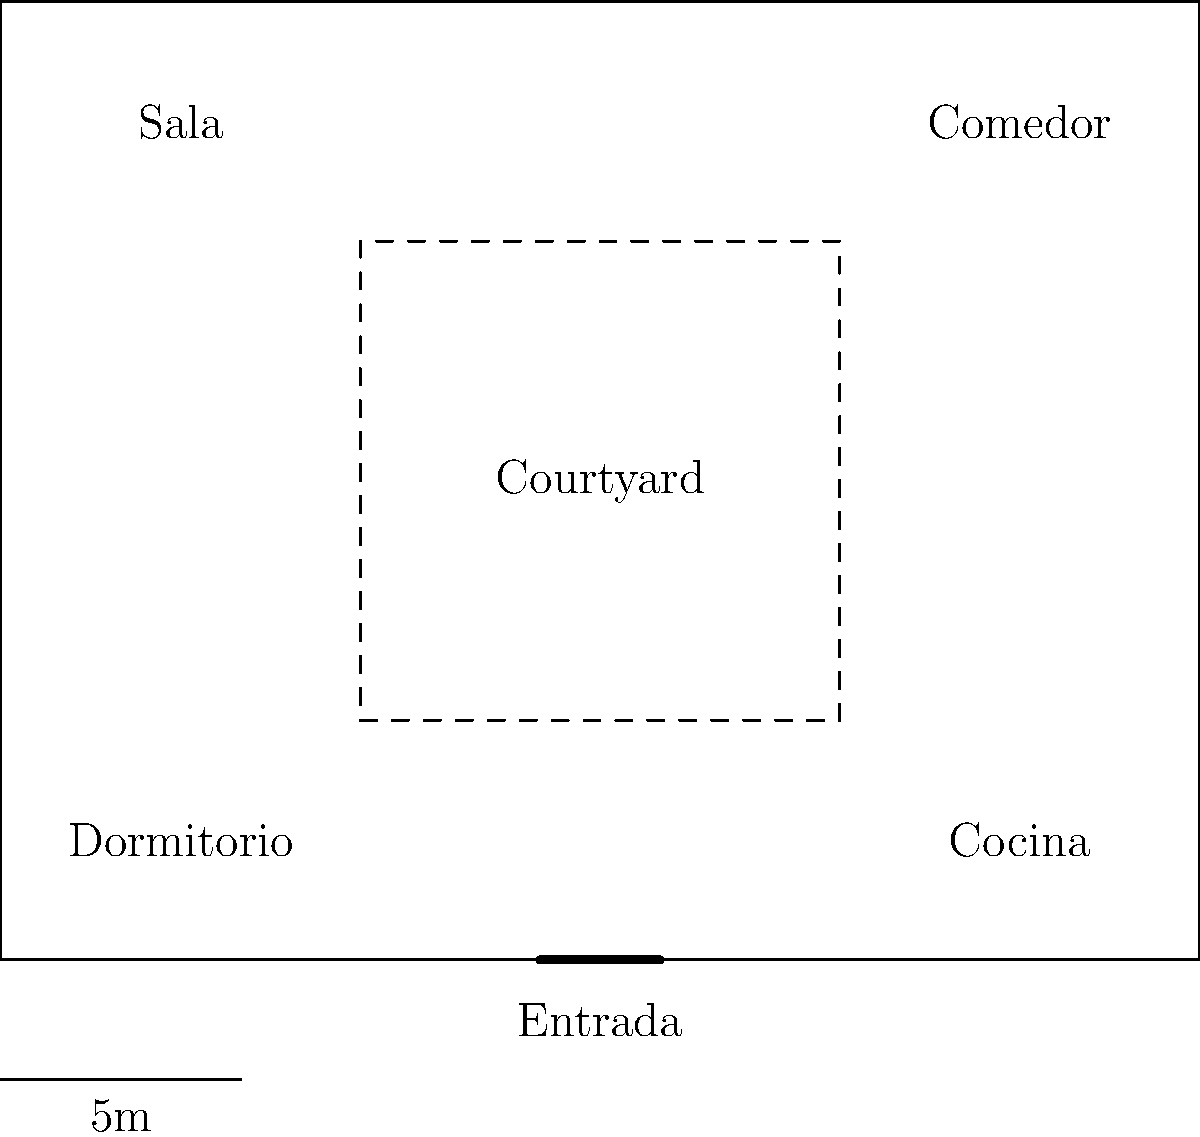In the floor plan of a typical Cuban colonial courtyard house shown above, which architectural element serves as the central organizing feature of the home's layout? To answer this question, let's analyze the floor plan step-by-step:

1. The diagram shows a rectangular structure with rooms arranged around a central space.

2. This central space is labeled "Courtyard" and is represented by a dashed line, indicating an open area.

3. The rooms are arranged around this courtyard:
   - "Sala" (living room) and "Comedor" (dining room) are located on one side
   - "Dormitorio" (bedroom) and "Cocina" (kitchen) are on the opposite side

4. The entrance ("Entrada") is shown at the bottom of the diagram, leading directly to the courtyard area.

5. This layout is characteristic of Cuban colonial architecture, where the courtyard (or "patio") serves as the heart of the home.

6. The courtyard provides:
   - Natural light and ventilation to surrounding rooms
   - A central gathering space for family activities
   - A way to organize the home's circulation and access to different rooms

7. This design is a response to Cuba's tropical climate, allowing for air circulation and a cooler indoor environment.

Given these observations, it's clear that the courtyard is the central organizing feature of the home's layout, around which all other spaces are arranged.
Answer: The courtyard (patio) 